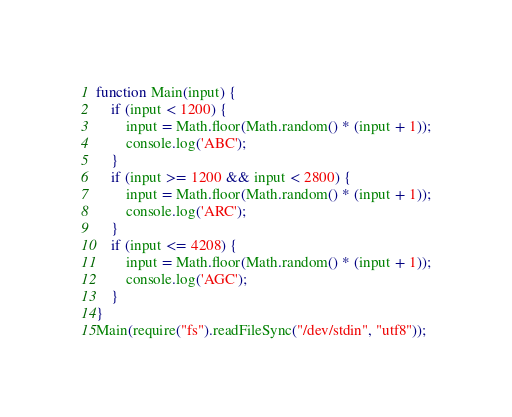<code> <loc_0><loc_0><loc_500><loc_500><_JavaScript_>function Main(input) {
    if (input < 1200) {
        input = Math.floor(Math.random() * (input + 1));
        console.log('ABC');
    }
    if (input >= 1200 && input < 2800) {
        input = Math.floor(Math.random() * (input + 1));
        console.log('ARC');
    }
    if (input <= 4208) {
        input = Math.floor(Math.random() * (input + 1));
        console.log('AGC');
    }
}
Main(require("fs").readFileSync("/dev/stdin", "utf8"));</code> 